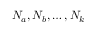<formula> <loc_0><loc_0><loc_500><loc_500>N _ { a } , N _ { b } , \dots , N _ { k }</formula> 